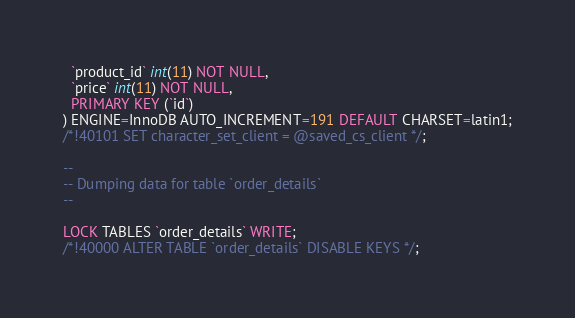<code> <loc_0><loc_0><loc_500><loc_500><_SQL_>  `product_id` int(11) NOT NULL,
  `price` int(11) NOT NULL,
  PRIMARY KEY (`id`)
) ENGINE=InnoDB AUTO_INCREMENT=191 DEFAULT CHARSET=latin1;
/*!40101 SET character_set_client = @saved_cs_client */;

--
-- Dumping data for table `order_details`
--

LOCK TABLES `order_details` WRITE;
/*!40000 ALTER TABLE `order_details` DISABLE KEYS */;</code> 